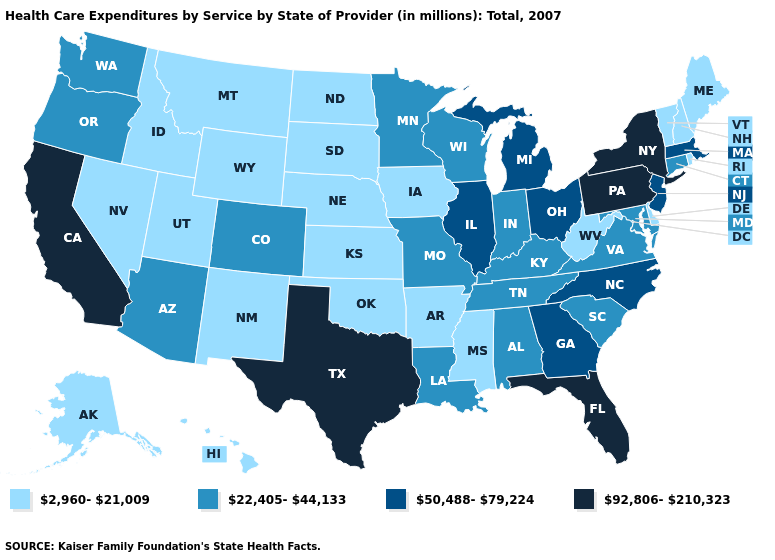What is the value of Nebraska?
Be succinct. 2,960-21,009. Name the states that have a value in the range 92,806-210,323?
Be succinct. California, Florida, New York, Pennsylvania, Texas. What is the value of West Virginia?
Write a very short answer. 2,960-21,009. Does Iowa have the highest value in the MidWest?
Write a very short answer. No. Does Georgia have a higher value than Oregon?
Short answer required. Yes. What is the lowest value in states that border Alabama?
Be succinct. 2,960-21,009. Name the states that have a value in the range 2,960-21,009?
Answer briefly. Alaska, Arkansas, Delaware, Hawaii, Idaho, Iowa, Kansas, Maine, Mississippi, Montana, Nebraska, Nevada, New Hampshire, New Mexico, North Dakota, Oklahoma, Rhode Island, South Dakota, Utah, Vermont, West Virginia, Wyoming. Which states have the highest value in the USA?
Short answer required. California, Florida, New York, Pennsylvania, Texas. Does Kansas have the highest value in the MidWest?
Write a very short answer. No. What is the value of Ohio?
Give a very brief answer. 50,488-79,224. Which states have the lowest value in the USA?
Short answer required. Alaska, Arkansas, Delaware, Hawaii, Idaho, Iowa, Kansas, Maine, Mississippi, Montana, Nebraska, Nevada, New Hampshire, New Mexico, North Dakota, Oklahoma, Rhode Island, South Dakota, Utah, Vermont, West Virginia, Wyoming. Is the legend a continuous bar?
Write a very short answer. No. What is the highest value in the West ?
Concise answer only. 92,806-210,323. Is the legend a continuous bar?
Short answer required. No. What is the value of Maryland?
Write a very short answer. 22,405-44,133. 